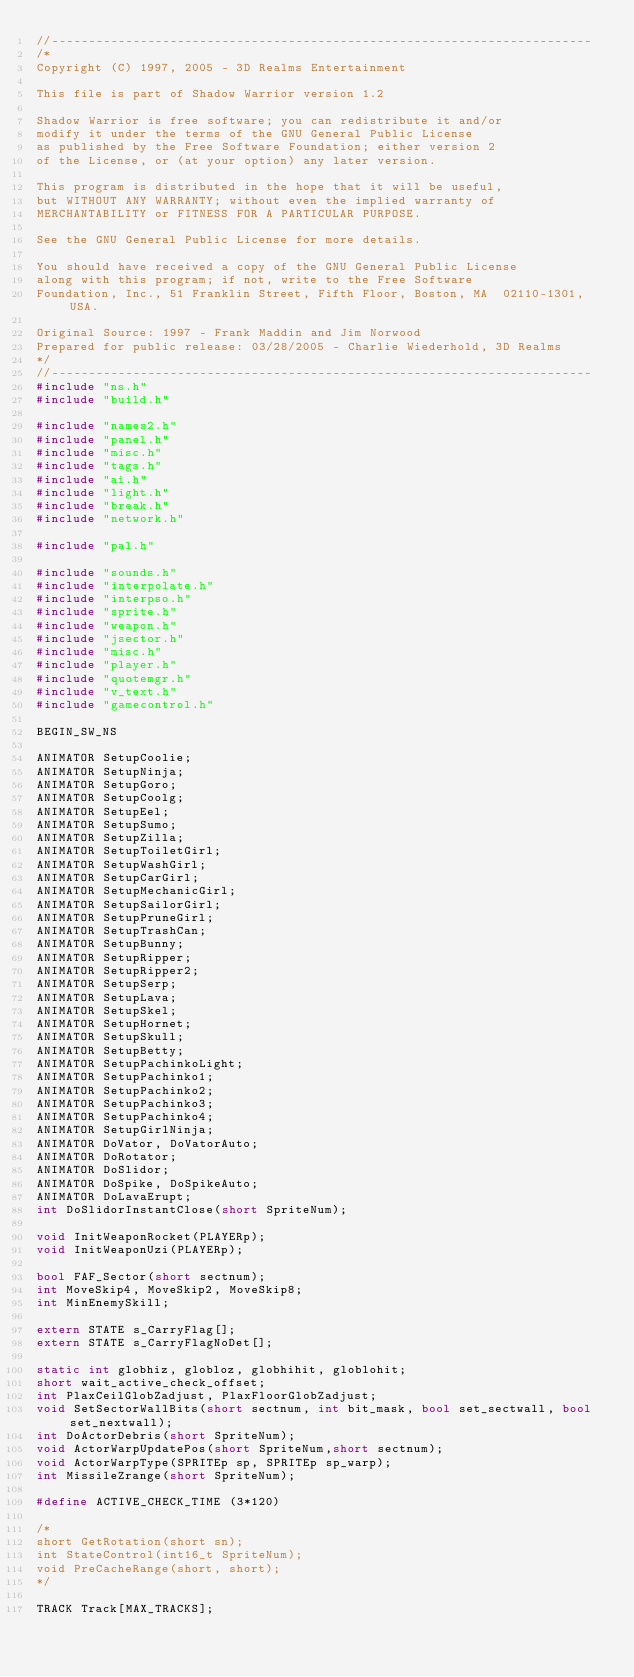Convert code to text. <code><loc_0><loc_0><loc_500><loc_500><_C++_>//-------------------------------------------------------------------------
/*
Copyright (C) 1997, 2005 - 3D Realms Entertainment

This file is part of Shadow Warrior version 1.2

Shadow Warrior is free software; you can redistribute it and/or
modify it under the terms of the GNU General Public License
as published by the Free Software Foundation; either version 2
of the License, or (at your option) any later version.

This program is distributed in the hope that it will be useful,
but WITHOUT ANY WARRANTY; without even the implied warranty of
MERCHANTABILITY or FITNESS FOR A PARTICULAR PURPOSE.

See the GNU General Public License for more details.

You should have received a copy of the GNU General Public License
along with this program; if not, write to the Free Software
Foundation, Inc., 51 Franklin Street, Fifth Floor, Boston, MA  02110-1301, USA.

Original Source: 1997 - Frank Maddin and Jim Norwood
Prepared for public release: 03/28/2005 - Charlie Wiederhold, 3D Realms
*/
//-------------------------------------------------------------------------
#include "ns.h"
#include "build.h"

#include "names2.h"
#include "panel.h"
#include "misc.h"
#include "tags.h"
#include "ai.h"
#include "light.h"
#include "break.h"
#include "network.h"

#include "pal.h"

#include "sounds.h"
#include "interpolate.h"
#include "interpso.h"
#include "sprite.h"
#include "weapon.h"
#include "jsector.h"
#include "misc.h"
#include "player.h"
#include "quotemgr.h"
#include "v_text.h"
#include "gamecontrol.h"

BEGIN_SW_NS

ANIMATOR SetupCoolie;
ANIMATOR SetupNinja;
ANIMATOR SetupGoro;
ANIMATOR SetupCoolg;
ANIMATOR SetupEel;
ANIMATOR SetupSumo;
ANIMATOR SetupZilla;
ANIMATOR SetupToiletGirl;
ANIMATOR SetupWashGirl;
ANIMATOR SetupCarGirl;
ANIMATOR SetupMechanicGirl;
ANIMATOR SetupSailorGirl;
ANIMATOR SetupPruneGirl;
ANIMATOR SetupTrashCan;
ANIMATOR SetupBunny;
ANIMATOR SetupRipper;
ANIMATOR SetupRipper2;
ANIMATOR SetupSerp;
ANIMATOR SetupLava;
ANIMATOR SetupSkel;
ANIMATOR SetupHornet;
ANIMATOR SetupSkull;
ANIMATOR SetupBetty;
ANIMATOR SetupPachinkoLight;
ANIMATOR SetupPachinko1;
ANIMATOR SetupPachinko2;
ANIMATOR SetupPachinko3;
ANIMATOR SetupPachinko4;
ANIMATOR SetupGirlNinja;
ANIMATOR DoVator, DoVatorAuto;
ANIMATOR DoRotator;
ANIMATOR DoSlidor;
ANIMATOR DoSpike, DoSpikeAuto;
ANIMATOR DoLavaErupt;
int DoSlidorInstantClose(short SpriteNum);

void InitWeaponRocket(PLAYERp);
void InitWeaponUzi(PLAYERp);

bool FAF_Sector(short sectnum);
int MoveSkip4, MoveSkip2, MoveSkip8;
int MinEnemySkill;

extern STATE s_CarryFlag[];
extern STATE s_CarryFlagNoDet[];

static int globhiz, globloz, globhihit, globlohit;
short wait_active_check_offset;
int PlaxCeilGlobZadjust, PlaxFloorGlobZadjust;
void SetSectorWallBits(short sectnum, int bit_mask, bool set_sectwall, bool set_nextwall);
int DoActorDebris(short SpriteNum);
void ActorWarpUpdatePos(short SpriteNum,short sectnum);
void ActorWarpType(SPRITEp sp, SPRITEp sp_warp);
int MissileZrange(short SpriteNum);

#define ACTIVE_CHECK_TIME (3*120)

/*
short GetRotation(short sn);
int StateControl(int16_t SpriteNum);
void PreCacheRange(short, short);
*/

TRACK Track[MAX_TRACKS];</code> 